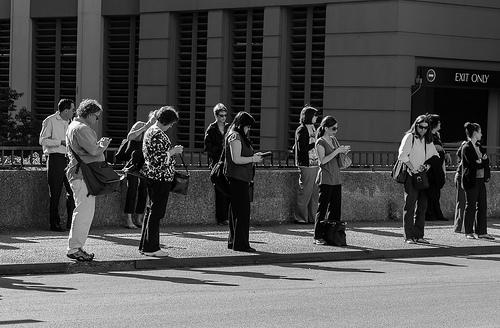In the context of product advertisement, describe the featured item related to the word "exit." A sign that reads "Exit Only" in white capital letters placed in the window of a building. Find the person who is wearing a gray shirt and describe their appearance for the referential expression grounding task. Young woman wearing sunglasses, gray shirt, and light-colored pants, standing and texting. Identify the main activity happening in the image. People standing on a city sidewalk, some of them texting. For the multi-choice VQA task, choose the correct description of an object near the group of people: Is it a green trash bin, a black purse, or a small red car? A black purse. Describe the attire of one woman in the picture. A woman wearing black pants, white shirt, and sunglasses. What can you find right behind the cement wall? A bush. Describe the location where the people are standing in this image. City sidewalk with a short concrete wall and a railing on top. What does the text on the sign near the group of people say? Exit Only. For the visual entailment task, what is the general atmosphere of the image based on the clothing and shadows? A sunny day in a city with people dressed in casual wear. What do the shadows on the street represent? Shadows of people standing on the sidewalk. 